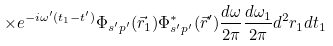Convert formula to latex. <formula><loc_0><loc_0><loc_500><loc_500>\times e ^ { - i \omega ^ { \prime } ( t _ { 1 } - t ^ { \prime } ) } \Phi _ { s ^ { \prime } p ^ { \prime } } ( \vec { r } _ { 1 } ) \Phi _ { s ^ { \prime } p ^ { \prime } } ^ { * } ( \vec { r } ^ { \prime } ) \frac { d \omega } { 2 \pi } \frac { d \omega _ { 1 } } { 2 \pi } d ^ { 2 } r _ { 1 } d t _ { 1 }</formula> 